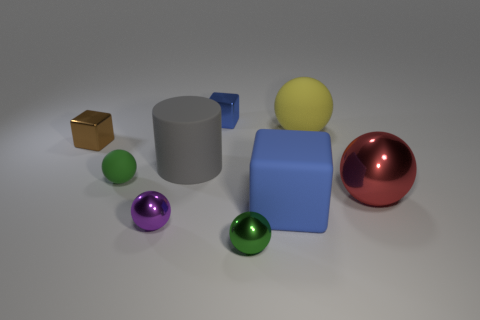What material is the purple thing that is the same shape as the red metal object?
Your response must be concise. Metal. There is a green sphere that is in front of the metal ball on the right side of the yellow sphere; what size is it?
Ensure brevity in your answer.  Small. Are any small gray matte cubes visible?
Provide a succinct answer. No. What material is the ball that is both to the right of the small purple object and in front of the big red thing?
Make the answer very short. Metal. Is the number of tiny shiny objects in front of the gray object greater than the number of green matte things that are in front of the purple metallic object?
Provide a succinct answer. Yes. Are there any gray rubber cylinders of the same size as the yellow rubber thing?
Ensure brevity in your answer.  Yes. There is a green sphere that is in front of the green ball behind the green thing right of the small blue thing; what size is it?
Offer a terse response. Small. The large shiny ball is what color?
Ensure brevity in your answer.  Red. Is the number of spheres right of the green metallic thing greater than the number of big red metal things?
Make the answer very short. Yes. What number of blue shiny blocks are right of the small purple shiny thing?
Offer a terse response. 1. 